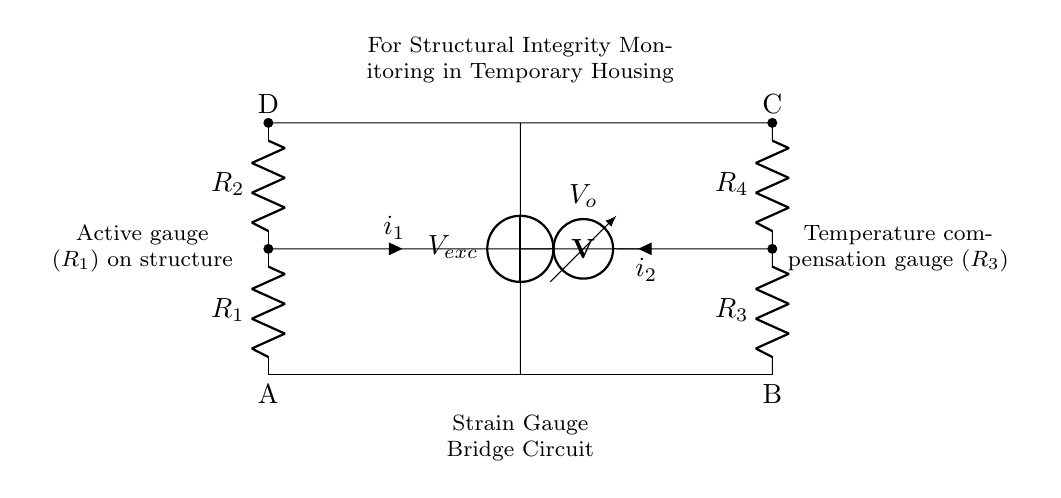What type of circuit is represented here? The circuit is a bridge circuit configuration known as a strain gauge bridge, used to measure deformation or strain on a structure.
Answer: strain gauge bridge What do resistors R1 and R3 represent in this circuit? Resistor R1 represents the active strain gauge that measures the structural deformation, while R3 is the temperature compensation gauge that helps account for changes in resistance due to temperature variations.
Answer: active gauge and temperature compensation gauge What is V_o in the circuit? V_o represents the output voltage measured across the bridge circuit, which indicates the amount of strain experienced by the structure.
Answer: output voltage How many resistors are present in this circuit? The circuit has four resistors total: R1, R2, R3, and R4.
Answer: four What happens to V_o when the structure undergoes strain? When the structure experiences strain, the active gauge changes resistance, leading to a change in V_o, which reflects the strain level in the structure.
Answer: change in V_o What is the purpose of including R4 in the circuit? R4 serves as a reference resistor, completing the bridge and ensuring that the circuit can accurately measure the difference in voltage caused by strain in R1.
Answer: reference resistor 